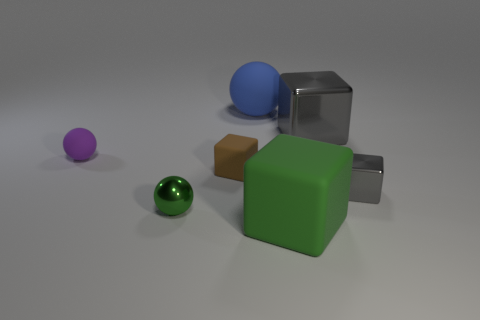There is a tiny green object that is the same shape as the big blue thing; what is its material?
Offer a very short reply. Metal. What shape is the shiny thing on the left side of the matte sphere that is behind the matte thing to the left of the green shiny object?
Offer a terse response. Sphere. How many other things are there of the same material as the large gray thing?
Keep it short and to the point. 2. What number of objects are rubber objects that are behind the small gray metallic thing or large blue matte cylinders?
Give a very brief answer. 3. The green thing that is to the left of the rubber sphere that is right of the tiny purple rubber ball is what shape?
Ensure brevity in your answer.  Sphere. There is a small rubber object to the left of the brown cube; does it have the same shape as the small gray metal object?
Ensure brevity in your answer.  No. There is a metal thing that is to the left of the blue rubber object; what color is it?
Provide a succinct answer. Green. What number of cubes are small purple objects or brown rubber things?
Offer a very short reply. 1. There is a matte block that is behind the small metal thing on the left side of the big blue sphere; what is its size?
Provide a short and direct response. Small. There is a metallic sphere; is it the same color as the tiny metallic object that is to the right of the big rubber ball?
Your response must be concise. No. 